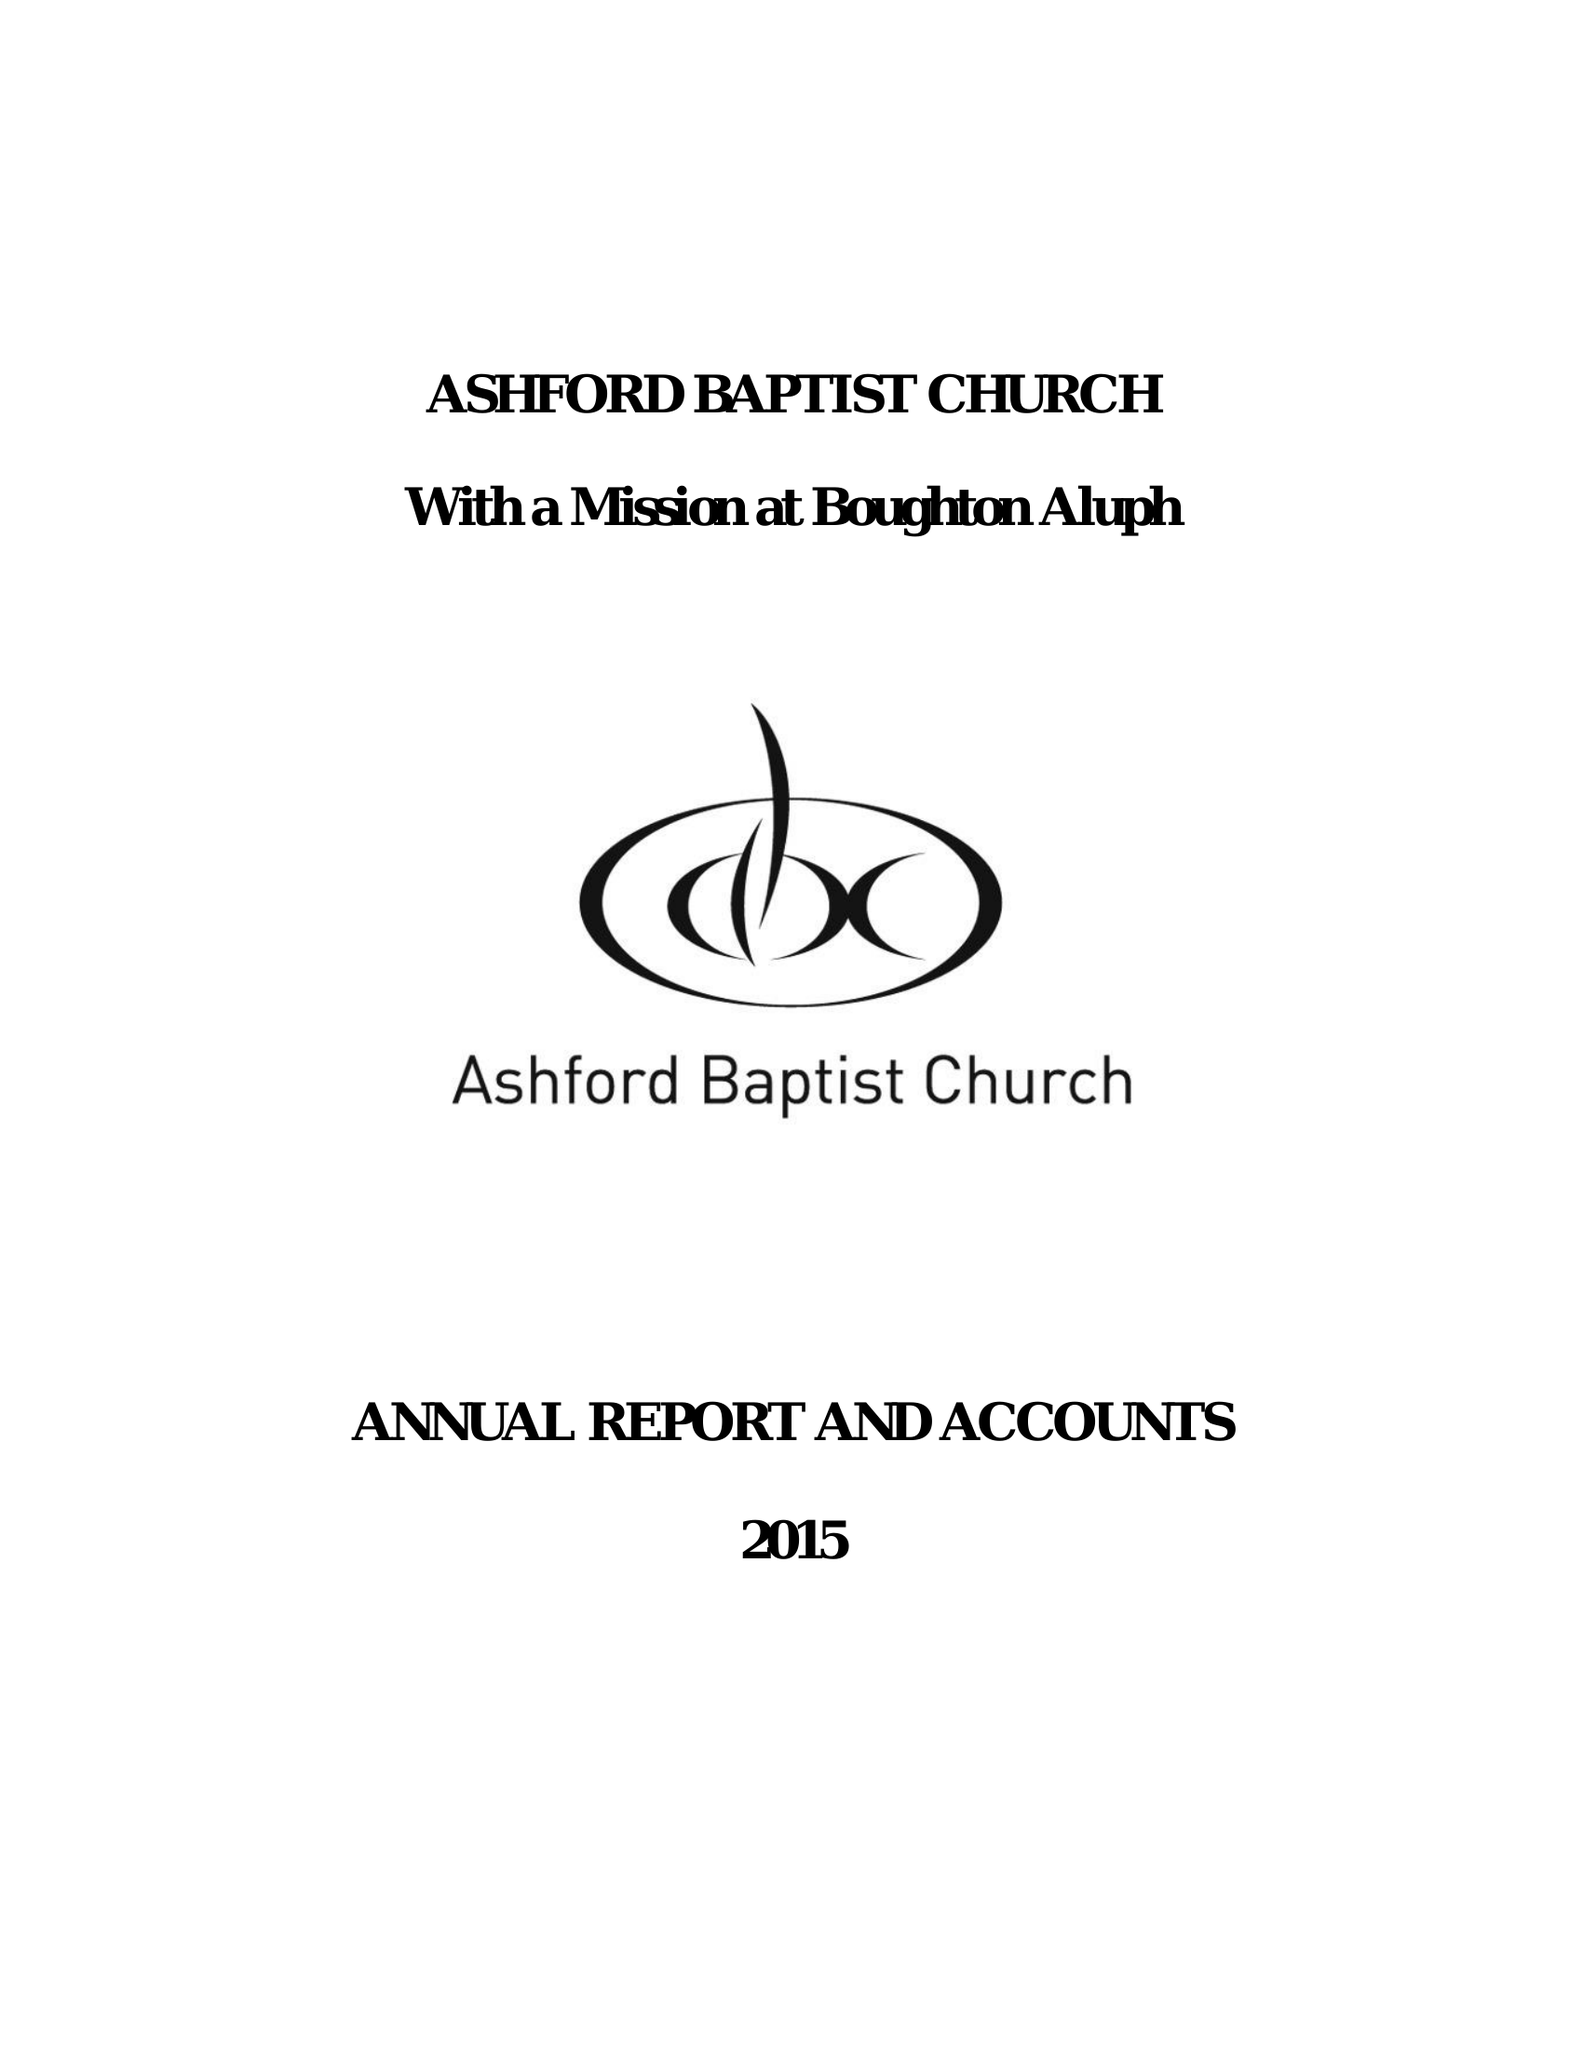What is the value for the income_annually_in_british_pounds?
Answer the question using a single word or phrase. 222644.00 